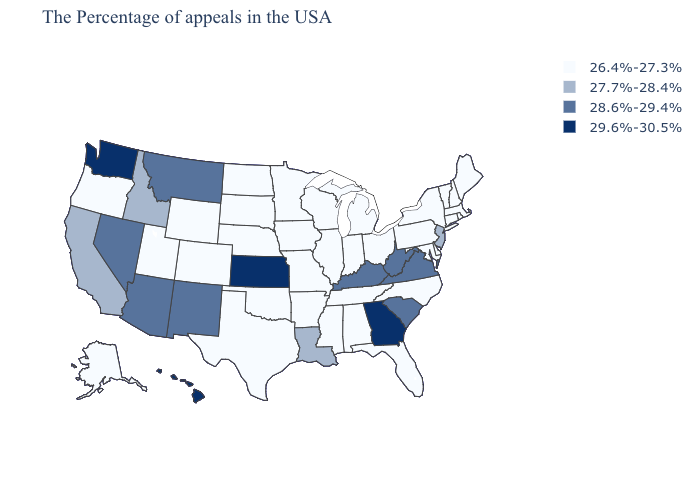Which states hav the highest value in the South?
Be succinct. Georgia. What is the lowest value in the USA?
Give a very brief answer. 26.4%-27.3%. Name the states that have a value in the range 27.7%-28.4%?
Give a very brief answer. New Jersey, Louisiana, Idaho, California. Among the states that border Texas , which have the lowest value?
Answer briefly. Arkansas, Oklahoma. Name the states that have a value in the range 26.4%-27.3%?
Answer briefly. Maine, Massachusetts, Rhode Island, New Hampshire, Vermont, Connecticut, New York, Delaware, Maryland, Pennsylvania, North Carolina, Ohio, Florida, Michigan, Indiana, Alabama, Tennessee, Wisconsin, Illinois, Mississippi, Missouri, Arkansas, Minnesota, Iowa, Nebraska, Oklahoma, Texas, South Dakota, North Dakota, Wyoming, Colorado, Utah, Oregon, Alaska. Name the states that have a value in the range 27.7%-28.4%?
Write a very short answer. New Jersey, Louisiana, Idaho, California. What is the value of Minnesota?
Answer briefly. 26.4%-27.3%. Does Rhode Island have the highest value in the Northeast?
Short answer required. No. What is the lowest value in the USA?
Answer briefly. 26.4%-27.3%. What is the value of Iowa?
Short answer required. 26.4%-27.3%. Does Utah have the lowest value in the West?
Short answer required. Yes. Name the states that have a value in the range 26.4%-27.3%?
Be succinct. Maine, Massachusetts, Rhode Island, New Hampshire, Vermont, Connecticut, New York, Delaware, Maryland, Pennsylvania, North Carolina, Ohio, Florida, Michigan, Indiana, Alabama, Tennessee, Wisconsin, Illinois, Mississippi, Missouri, Arkansas, Minnesota, Iowa, Nebraska, Oklahoma, Texas, South Dakota, North Dakota, Wyoming, Colorado, Utah, Oregon, Alaska. Does the first symbol in the legend represent the smallest category?
Quick response, please. Yes. What is the value of Kansas?
Answer briefly. 29.6%-30.5%. Which states have the lowest value in the USA?
Keep it brief. Maine, Massachusetts, Rhode Island, New Hampshire, Vermont, Connecticut, New York, Delaware, Maryland, Pennsylvania, North Carolina, Ohio, Florida, Michigan, Indiana, Alabama, Tennessee, Wisconsin, Illinois, Mississippi, Missouri, Arkansas, Minnesota, Iowa, Nebraska, Oklahoma, Texas, South Dakota, North Dakota, Wyoming, Colorado, Utah, Oregon, Alaska. 